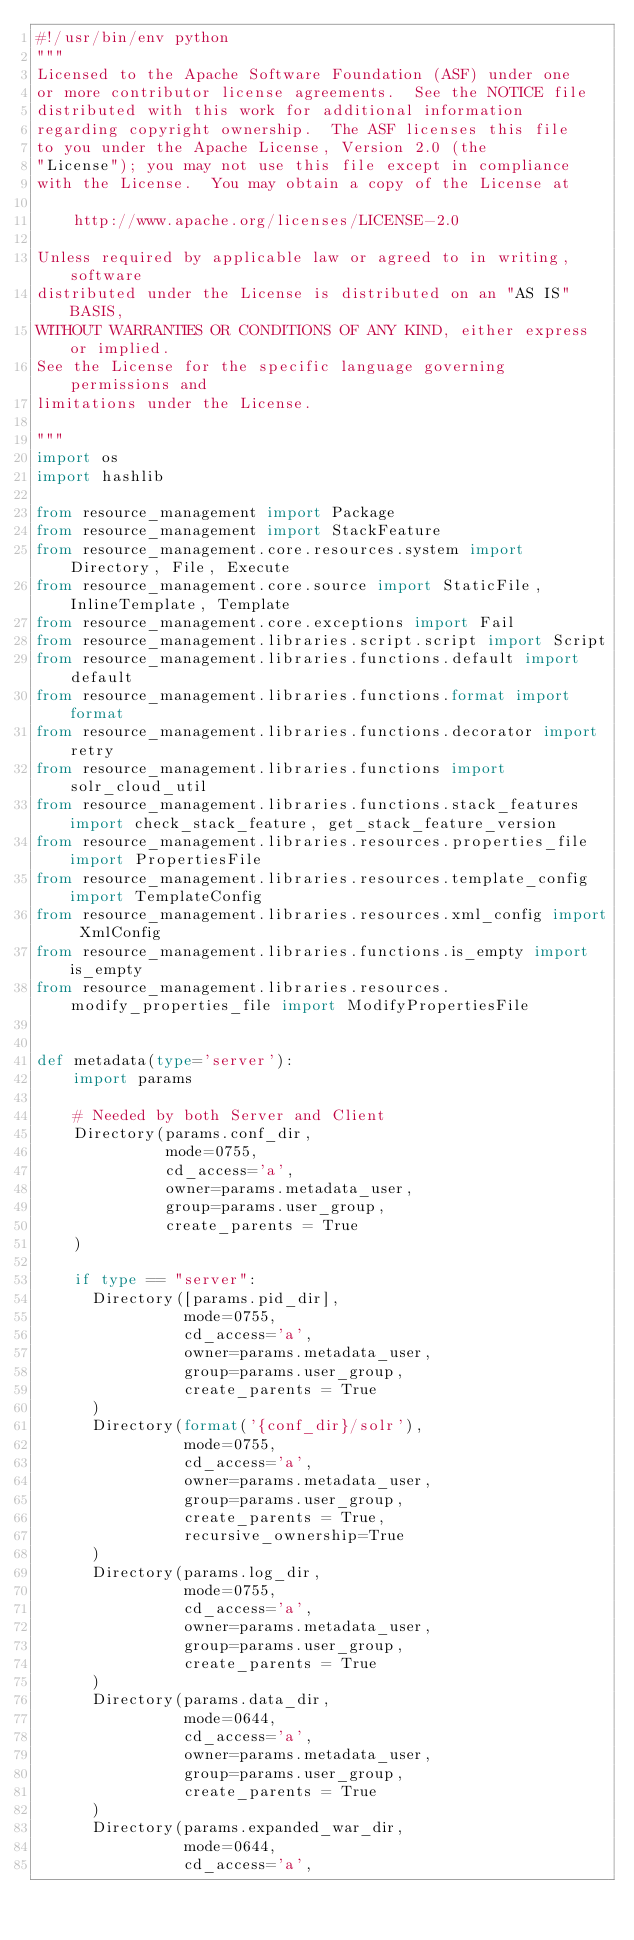<code> <loc_0><loc_0><loc_500><loc_500><_Python_>#!/usr/bin/env python
"""
Licensed to the Apache Software Foundation (ASF) under one
or more contributor license agreements.  See the NOTICE file
distributed with this work for additional information
regarding copyright ownership.  The ASF licenses this file
to you under the Apache License, Version 2.0 (the
"License"); you may not use this file except in compliance
with the License.  You may obtain a copy of the License at

    http://www.apache.org/licenses/LICENSE-2.0

Unless required by applicable law or agreed to in writing, software
distributed under the License is distributed on an "AS IS" BASIS,
WITHOUT WARRANTIES OR CONDITIONS OF ANY KIND, either express or implied.
See the License for the specific language governing permissions and
limitations under the License.

"""
import os
import hashlib

from resource_management import Package
from resource_management import StackFeature
from resource_management.core.resources.system import Directory, File, Execute
from resource_management.core.source import StaticFile, InlineTemplate, Template
from resource_management.core.exceptions import Fail
from resource_management.libraries.script.script import Script
from resource_management.libraries.functions.default import default
from resource_management.libraries.functions.format import format
from resource_management.libraries.functions.decorator import retry
from resource_management.libraries.functions import solr_cloud_util
from resource_management.libraries.functions.stack_features import check_stack_feature, get_stack_feature_version
from resource_management.libraries.resources.properties_file import PropertiesFile
from resource_management.libraries.resources.template_config import TemplateConfig
from resource_management.libraries.resources.xml_config import XmlConfig
from resource_management.libraries.functions.is_empty import is_empty
from resource_management.libraries.resources.modify_properties_file import ModifyPropertiesFile


def metadata(type='server'):
    import params

    # Needed by both Server and Client
    Directory(params.conf_dir,
              mode=0755,
              cd_access='a',
              owner=params.metadata_user,
              group=params.user_group,
              create_parents = True
    )

    if type == "server":
      Directory([params.pid_dir],
                mode=0755,
                cd_access='a',
                owner=params.metadata_user,
                group=params.user_group,
                create_parents = True
      )
      Directory(format('{conf_dir}/solr'),
                mode=0755,
                cd_access='a',
                owner=params.metadata_user,
                group=params.user_group,
                create_parents = True,
                recursive_ownership=True
      )
      Directory(params.log_dir,
                mode=0755,
                cd_access='a',
                owner=params.metadata_user,
                group=params.user_group,
                create_parents = True
      )
      Directory(params.data_dir,
                mode=0644,
                cd_access='a',
                owner=params.metadata_user,
                group=params.user_group,
                create_parents = True
      )
      Directory(params.expanded_war_dir,
                mode=0644,
                cd_access='a',</code> 